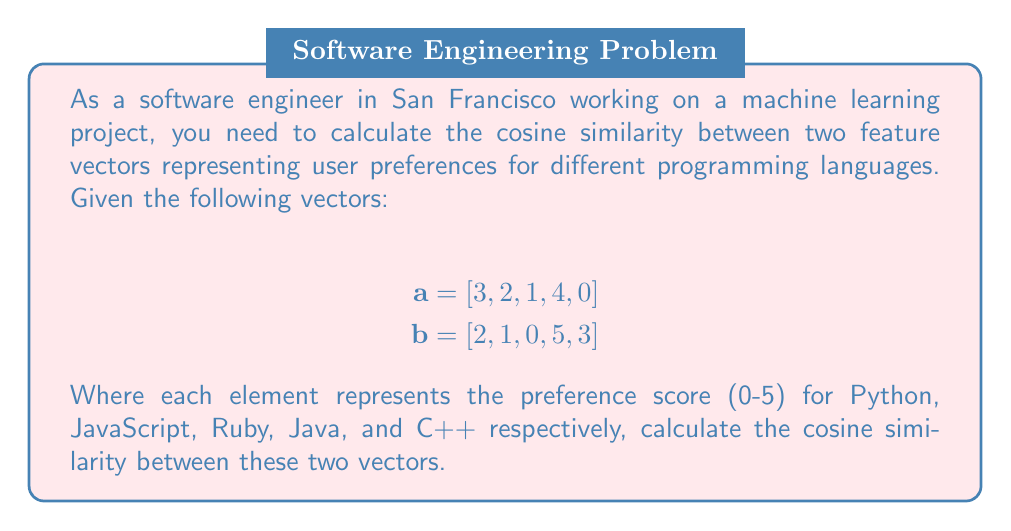Teach me how to tackle this problem. To calculate the cosine similarity between two vectors $\mathbf{a}$ and $\mathbf{b}$, we use the formula:

$$\text{cosine similarity} = \frac{\mathbf{a} \cdot \mathbf{b}}{\|\mathbf{a}\| \|\mathbf{b}\|}$$

Where $\mathbf{a} \cdot \mathbf{b}$ is the dot product of the vectors, and $\|\mathbf{a}\|$ and $\|\mathbf{b}\|$ are the magnitudes (Euclidean norms) of the vectors.

Step 1: Calculate the dot product $\mathbf{a} \cdot \mathbf{b}$
$$(3 \times 2) + (2 \times 1) + (1 \times 0) + (4 \times 5) + (0 \times 3) = 6 + 2 + 0 + 20 + 0 = 28$$

Step 2: Calculate $\|\mathbf{a}\|$
$$\|\mathbf{a}\| = \sqrt{3^2 + 2^2 + 1^2 + 4^2 + 0^2} = \sqrt{9 + 4 + 1 + 16 + 0} = \sqrt{30} \approx 5.477$$

Step 3: Calculate $\|\mathbf{b}\|$
$$\|\mathbf{b}\| = \sqrt{2^2 + 1^2 + 0^2 + 5^2 + 3^2} = \sqrt{4 + 1 + 0 + 25 + 9} = \sqrt{39} \approx 6.245$$

Step 4: Apply the cosine similarity formula
$$\text{cosine similarity} = \frac{28}{5.477 \times 6.245} \approx 0.819$$
Answer: $0.819$ 